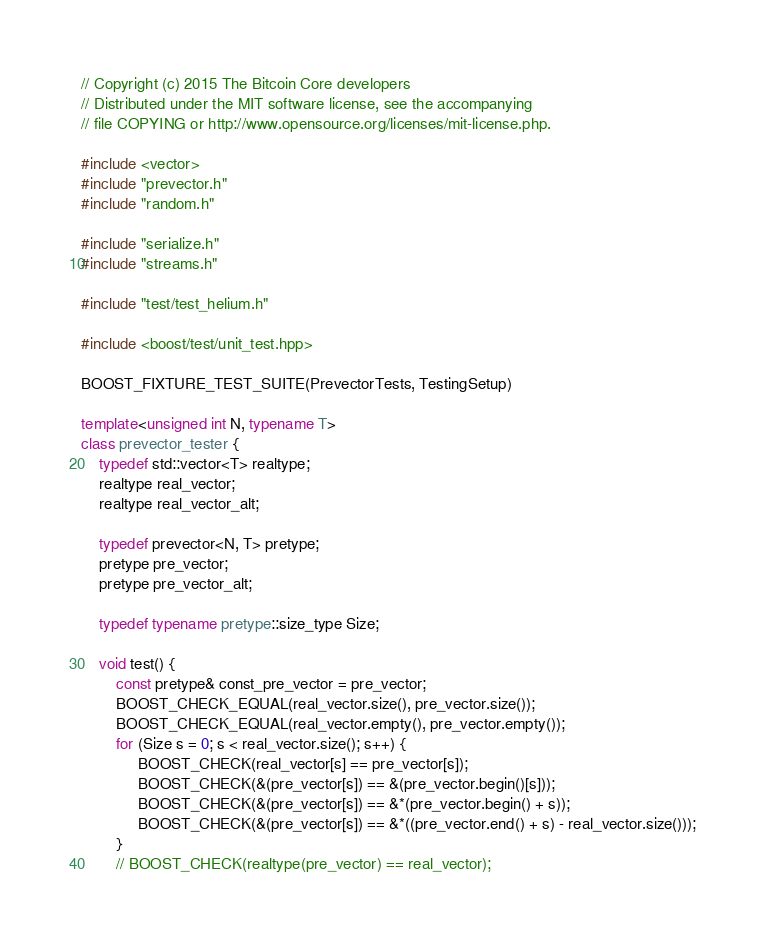<code> <loc_0><loc_0><loc_500><loc_500><_C++_>// Copyright (c) 2015 The Bitcoin Core developers
// Distributed under the MIT software license, see the accompanying
// file COPYING or http://www.opensource.org/licenses/mit-license.php.

#include <vector>
#include "prevector.h"
#include "random.h"

#include "serialize.h"
#include "streams.h"

#include "test/test_helium.h"

#include <boost/test/unit_test.hpp>

BOOST_FIXTURE_TEST_SUITE(PrevectorTests, TestingSetup)

template<unsigned int N, typename T>
class prevector_tester {
    typedef std::vector<T> realtype;
    realtype real_vector;
    realtype real_vector_alt;

    typedef prevector<N, T> pretype;
    pretype pre_vector;
    pretype pre_vector_alt;

    typedef typename pretype::size_type Size;

    void test() {
        const pretype& const_pre_vector = pre_vector;
        BOOST_CHECK_EQUAL(real_vector.size(), pre_vector.size());
        BOOST_CHECK_EQUAL(real_vector.empty(), pre_vector.empty());
        for (Size s = 0; s < real_vector.size(); s++) {
             BOOST_CHECK(real_vector[s] == pre_vector[s]);
             BOOST_CHECK(&(pre_vector[s]) == &(pre_vector.begin()[s]));
             BOOST_CHECK(&(pre_vector[s]) == &*(pre_vector.begin() + s));
             BOOST_CHECK(&(pre_vector[s]) == &*((pre_vector.end() + s) - real_vector.size()));
        }
        // BOOST_CHECK(realtype(pre_vector) == real_vector);</code> 